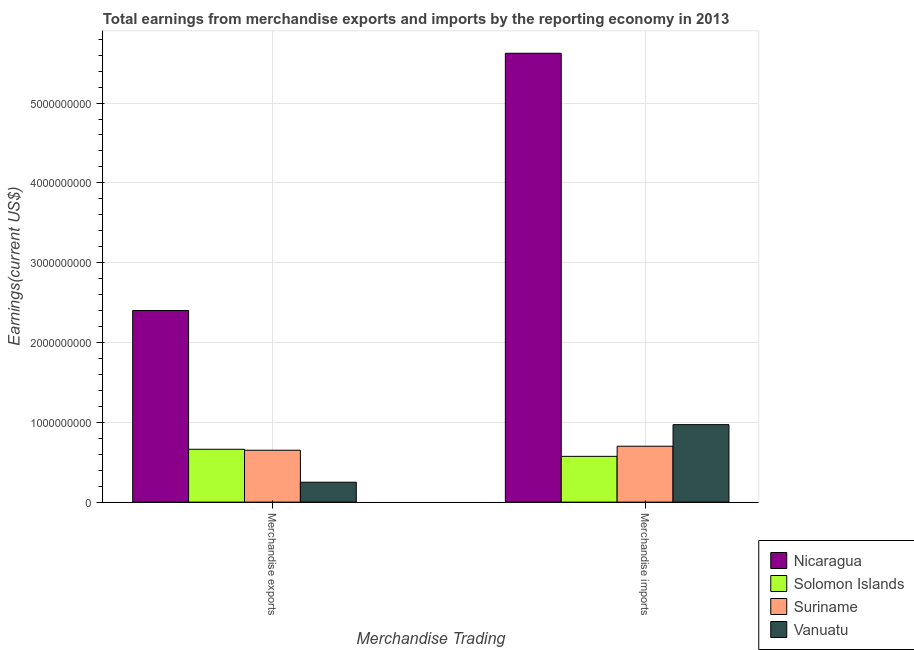How many different coloured bars are there?
Your answer should be compact. 4. Are the number of bars on each tick of the X-axis equal?
Give a very brief answer. Yes. How many bars are there on the 2nd tick from the left?
Your response must be concise. 4. What is the earnings from merchandise imports in Suriname?
Your answer should be very brief. 7.00e+08. Across all countries, what is the maximum earnings from merchandise exports?
Offer a terse response. 2.40e+09. Across all countries, what is the minimum earnings from merchandise imports?
Make the answer very short. 5.73e+08. In which country was the earnings from merchandise imports maximum?
Offer a terse response. Nicaragua. In which country was the earnings from merchandise imports minimum?
Your answer should be compact. Solomon Islands. What is the total earnings from merchandise exports in the graph?
Your answer should be very brief. 3.96e+09. What is the difference between the earnings from merchandise imports in Suriname and that in Solomon Islands?
Offer a terse response. 1.27e+08. What is the difference between the earnings from merchandise imports in Suriname and the earnings from merchandise exports in Nicaragua?
Your answer should be compact. -1.70e+09. What is the average earnings from merchandise imports per country?
Provide a succinct answer. 1.97e+09. What is the difference between the earnings from merchandise exports and earnings from merchandise imports in Nicaragua?
Provide a succinct answer. -3.22e+09. What is the ratio of the earnings from merchandise exports in Vanuatu to that in Nicaragua?
Provide a succinct answer. 0.1. What does the 2nd bar from the left in Merchandise exports represents?
Provide a succinct answer. Solomon Islands. What does the 4th bar from the right in Merchandise exports represents?
Make the answer very short. Nicaragua. How many bars are there?
Make the answer very short. 8. What is the difference between two consecutive major ticks on the Y-axis?
Keep it short and to the point. 1.00e+09. Are the values on the major ticks of Y-axis written in scientific E-notation?
Offer a very short reply. No. Does the graph contain any zero values?
Keep it short and to the point. No. Does the graph contain grids?
Your response must be concise. Yes. Where does the legend appear in the graph?
Your answer should be compact. Bottom right. How many legend labels are there?
Your response must be concise. 4. How are the legend labels stacked?
Keep it short and to the point. Vertical. What is the title of the graph?
Offer a terse response. Total earnings from merchandise exports and imports by the reporting economy in 2013. Does "Belgium" appear as one of the legend labels in the graph?
Keep it short and to the point. No. What is the label or title of the X-axis?
Provide a short and direct response. Merchandise Trading. What is the label or title of the Y-axis?
Ensure brevity in your answer.  Earnings(current US$). What is the Earnings(current US$) in Nicaragua in Merchandise exports?
Offer a very short reply. 2.40e+09. What is the Earnings(current US$) of Solomon Islands in Merchandise exports?
Give a very brief answer. 6.62e+08. What is the Earnings(current US$) of Suriname in Merchandise exports?
Offer a terse response. 6.50e+08. What is the Earnings(current US$) of Vanuatu in Merchandise exports?
Offer a very short reply. 2.50e+08. What is the Earnings(current US$) of Nicaragua in Merchandise imports?
Keep it short and to the point. 5.62e+09. What is the Earnings(current US$) of Solomon Islands in Merchandise imports?
Your answer should be compact. 5.73e+08. What is the Earnings(current US$) of Suriname in Merchandise imports?
Your answer should be compact. 7.00e+08. What is the Earnings(current US$) of Vanuatu in Merchandise imports?
Make the answer very short. 9.71e+08. Across all Merchandise Trading, what is the maximum Earnings(current US$) in Nicaragua?
Give a very brief answer. 5.62e+09. Across all Merchandise Trading, what is the maximum Earnings(current US$) in Solomon Islands?
Keep it short and to the point. 6.62e+08. Across all Merchandise Trading, what is the maximum Earnings(current US$) of Suriname?
Your answer should be compact. 7.00e+08. Across all Merchandise Trading, what is the maximum Earnings(current US$) in Vanuatu?
Offer a terse response. 9.71e+08. Across all Merchandise Trading, what is the minimum Earnings(current US$) in Nicaragua?
Your answer should be very brief. 2.40e+09. Across all Merchandise Trading, what is the minimum Earnings(current US$) of Solomon Islands?
Keep it short and to the point. 5.73e+08. Across all Merchandise Trading, what is the minimum Earnings(current US$) in Suriname?
Your answer should be compact. 6.50e+08. Across all Merchandise Trading, what is the minimum Earnings(current US$) of Vanuatu?
Give a very brief answer. 2.50e+08. What is the total Earnings(current US$) in Nicaragua in the graph?
Provide a short and direct response. 8.02e+09. What is the total Earnings(current US$) in Solomon Islands in the graph?
Your answer should be compact. 1.24e+09. What is the total Earnings(current US$) in Suriname in the graph?
Ensure brevity in your answer.  1.35e+09. What is the total Earnings(current US$) of Vanuatu in the graph?
Make the answer very short. 1.22e+09. What is the difference between the Earnings(current US$) in Nicaragua in Merchandise exports and that in Merchandise imports?
Give a very brief answer. -3.22e+09. What is the difference between the Earnings(current US$) in Solomon Islands in Merchandise exports and that in Merchandise imports?
Your response must be concise. 8.86e+07. What is the difference between the Earnings(current US$) in Suriname in Merchandise exports and that in Merchandise imports?
Provide a short and direct response. -5.03e+07. What is the difference between the Earnings(current US$) of Vanuatu in Merchandise exports and that in Merchandise imports?
Your response must be concise. -7.21e+08. What is the difference between the Earnings(current US$) of Nicaragua in Merchandise exports and the Earnings(current US$) of Solomon Islands in Merchandise imports?
Offer a very short reply. 1.83e+09. What is the difference between the Earnings(current US$) of Nicaragua in Merchandise exports and the Earnings(current US$) of Suriname in Merchandise imports?
Your answer should be compact. 1.70e+09. What is the difference between the Earnings(current US$) in Nicaragua in Merchandise exports and the Earnings(current US$) in Vanuatu in Merchandise imports?
Ensure brevity in your answer.  1.43e+09. What is the difference between the Earnings(current US$) in Solomon Islands in Merchandise exports and the Earnings(current US$) in Suriname in Merchandise imports?
Your response must be concise. -3.83e+07. What is the difference between the Earnings(current US$) in Solomon Islands in Merchandise exports and the Earnings(current US$) in Vanuatu in Merchandise imports?
Keep it short and to the point. -3.09e+08. What is the difference between the Earnings(current US$) of Suriname in Merchandise exports and the Earnings(current US$) of Vanuatu in Merchandise imports?
Offer a very short reply. -3.21e+08. What is the average Earnings(current US$) in Nicaragua per Merchandise Trading?
Your answer should be compact. 4.01e+09. What is the average Earnings(current US$) in Solomon Islands per Merchandise Trading?
Your answer should be compact. 6.18e+08. What is the average Earnings(current US$) of Suriname per Merchandise Trading?
Offer a terse response. 6.75e+08. What is the average Earnings(current US$) in Vanuatu per Merchandise Trading?
Offer a very short reply. 6.10e+08. What is the difference between the Earnings(current US$) in Nicaragua and Earnings(current US$) in Solomon Islands in Merchandise exports?
Ensure brevity in your answer.  1.74e+09. What is the difference between the Earnings(current US$) in Nicaragua and Earnings(current US$) in Suriname in Merchandise exports?
Make the answer very short. 1.75e+09. What is the difference between the Earnings(current US$) of Nicaragua and Earnings(current US$) of Vanuatu in Merchandise exports?
Your answer should be very brief. 2.15e+09. What is the difference between the Earnings(current US$) in Solomon Islands and Earnings(current US$) in Suriname in Merchandise exports?
Keep it short and to the point. 1.20e+07. What is the difference between the Earnings(current US$) of Solomon Islands and Earnings(current US$) of Vanuatu in Merchandise exports?
Provide a succinct answer. 4.13e+08. What is the difference between the Earnings(current US$) of Suriname and Earnings(current US$) of Vanuatu in Merchandise exports?
Your answer should be very brief. 4.01e+08. What is the difference between the Earnings(current US$) in Nicaragua and Earnings(current US$) in Solomon Islands in Merchandise imports?
Your answer should be compact. 5.05e+09. What is the difference between the Earnings(current US$) of Nicaragua and Earnings(current US$) of Suriname in Merchandise imports?
Make the answer very short. 4.92e+09. What is the difference between the Earnings(current US$) in Nicaragua and Earnings(current US$) in Vanuatu in Merchandise imports?
Ensure brevity in your answer.  4.65e+09. What is the difference between the Earnings(current US$) of Solomon Islands and Earnings(current US$) of Suriname in Merchandise imports?
Your answer should be very brief. -1.27e+08. What is the difference between the Earnings(current US$) in Solomon Islands and Earnings(current US$) in Vanuatu in Merchandise imports?
Your answer should be very brief. -3.97e+08. What is the difference between the Earnings(current US$) of Suriname and Earnings(current US$) of Vanuatu in Merchandise imports?
Provide a short and direct response. -2.70e+08. What is the ratio of the Earnings(current US$) in Nicaragua in Merchandise exports to that in Merchandise imports?
Provide a short and direct response. 0.43. What is the ratio of the Earnings(current US$) of Solomon Islands in Merchandise exports to that in Merchandise imports?
Your answer should be compact. 1.15. What is the ratio of the Earnings(current US$) of Suriname in Merchandise exports to that in Merchandise imports?
Provide a short and direct response. 0.93. What is the ratio of the Earnings(current US$) of Vanuatu in Merchandise exports to that in Merchandise imports?
Offer a terse response. 0.26. What is the difference between the highest and the second highest Earnings(current US$) in Nicaragua?
Provide a short and direct response. 3.22e+09. What is the difference between the highest and the second highest Earnings(current US$) in Solomon Islands?
Your response must be concise. 8.86e+07. What is the difference between the highest and the second highest Earnings(current US$) of Suriname?
Your answer should be very brief. 5.03e+07. What is the difference between the highest and the second highest Earnings(current US$) in Vanuatu?
Your response must be concise. 7.21e+08. What is the difference between the highest and the lowest Earnings(current US$) of Nicaragua?
Keep it short and to the point. 3.22e+09. What is the difference between the highest and the lowest Earnings(current US$) in Solomon Islands?
Your response must be concise. 8.86e+07. What is the difference between the highest and the lowest Earnings(current US$) of Suriname?
Offer a terse response. 5.03e+07. What is the difference between the highest and the lowest Earnings(current US$) in Vanuatu?
Give a very brief answer. 7.21e+08. 